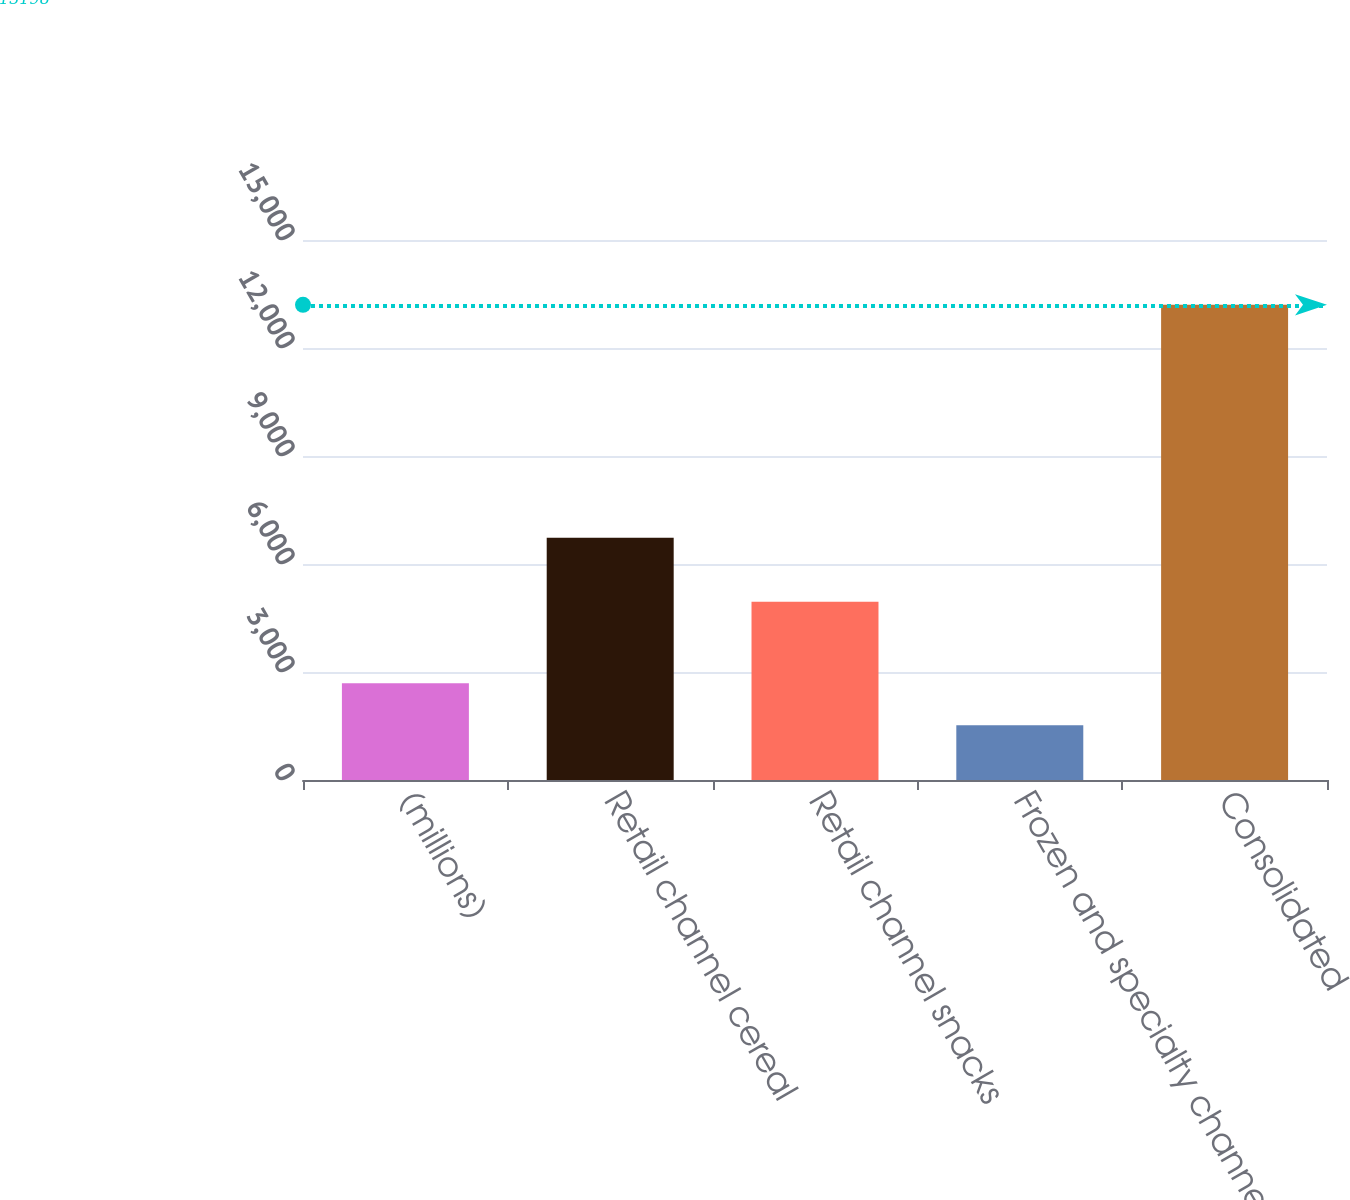<chart> <loc_0><loc_0><loc_500><loc_500><bar_chart><fcel>(millions)<fcel>Retail channel cereal<fcel>Retail channel snacks<fcel>Frozen and specialty channels<fcel>Consolidated<nl><fcel>2686.9<fcel>6730<fcel>4949<fcel>1519<fcel>13198<nl></chart> 